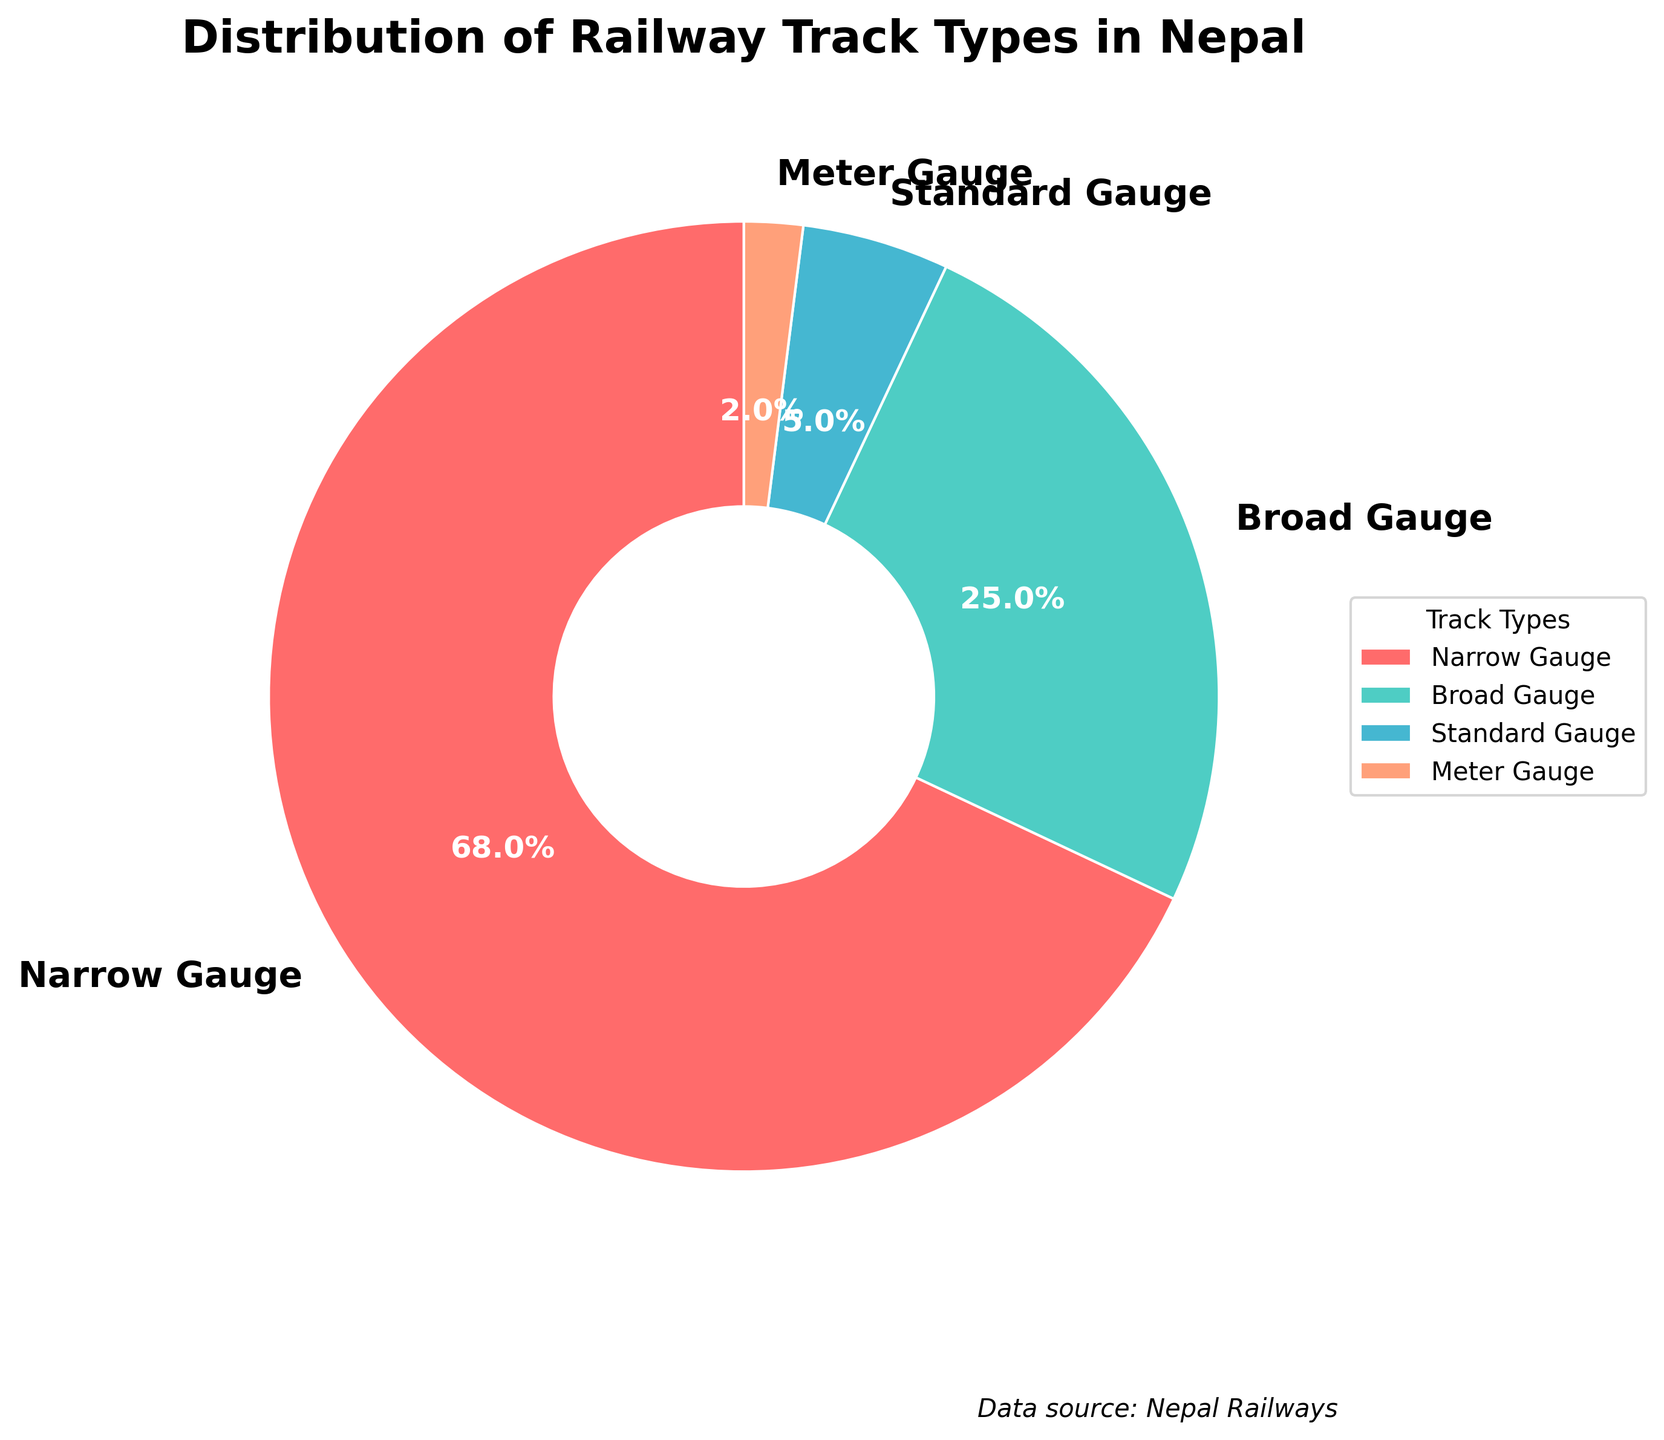What is the most common type of railway track in Nepal? The pie chart shows that the largest portion is labeled "Narrow Gauge" with 68%. Therefore, Narrow Gauge is the most common type.
Answer: Narrow Gauge Which railway track type has the smallest share in Nepal? According to the pie chart, the smallest portion is labeled "Meter Gauge" with just 2%. Therefore, Meter Gauge has the smallest share.
Answer: Meter Gauge How much combined percentage do Broad Gauge and Standard Gauge tracks account for? From the pie chart, Broad Gauge has 25% and Standard Gauge has 5%. Adding these percentages gives 25% + 5% = 30%.
Answer: 30% Is the percentage of Narrow Gauge tracks more than double that of Broad Gauge tracks? Narrow Gauge accounts for 68%, and Broad Gauge accounts for 25%. Doubling Broad Gauge would be 2 * 25% = 50%. Since 68% is greater than 50%, Narrow Gauge is indeed more than double Broad Gauge.
Answer: Yes Which track type is represented by the green color in the pie chart? The pie chart legend shows the color associated with each track type. The segment colored green corresponds to Broad Gauge.
Answer: Broad Gauge What is the difference in percentage between Narrow Gauge and Meter Gauge tracks? Narrow Gauge is 68% and Meter Gauge is 2%. The difference between them is 68% - 2% = 66%.
Answer: 66% How many times larger is the Narrow Gauge percentage compared to the Meter Gauge percentage? Narrow Gauge is 68%, and Meter Gauge is 2%. The ratio is calculated by dividing Narrow Gauge by Meter Gauge: 68% / 2% = 34. Therefore, Narrow Gauge is 34 times larger than Meter Gauge.
Answer: 34 times If the total length of railway tracks in Nepal is 1000 kilometers, approximately how many kilometers are Narrow Gauge tracks? Narrow Gauge makes up 68% of the tracks. 68% of 1000 kilometers is calculated as (68/100) * 1000 = 680 kilometers.
Answer: 680 kilometers Are there more Broad Gauge or Meter Gauge tracks? The pie chart shows Broad Gauge at 25% and Meter Gauge at 2%. 25% is greater than 2%, so there are more Broad Gauge tracks than Meter Gauge tracks.
Answer: Broad Gauge What percentage of tracks is either Narrow Gauge or Meter Gauge? The pie chart shows Narrow Gauge at 68% and Meter Gauge at 2%. Adding these percentages gives 68% + 2% = 70%.
Answer: 70% 